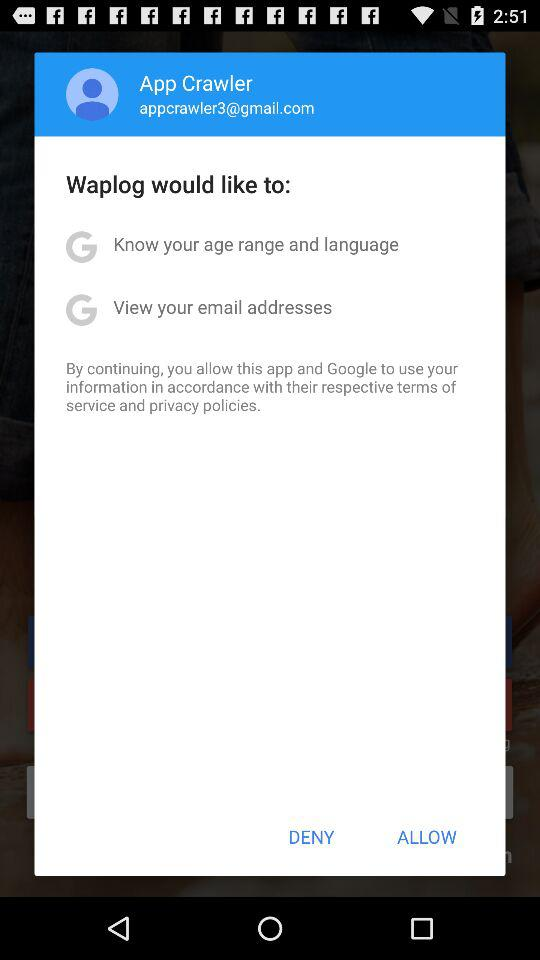What does waplog like to know? Waplog would like to know your age range and language, as well as view your email addresses. 